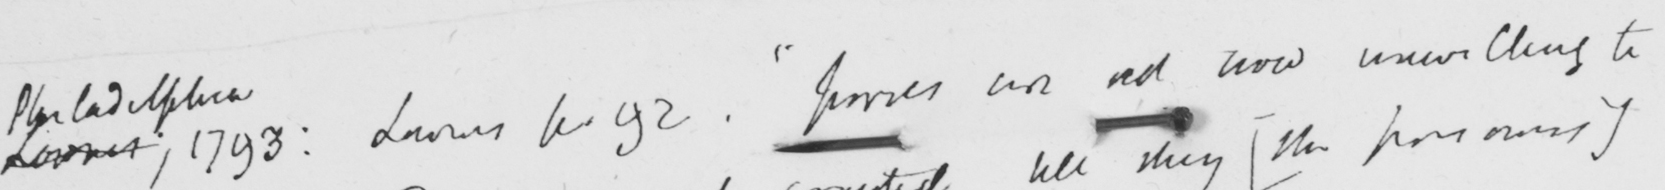What is written in this line of handwriting? <gap/>  ; 1793 :   <gap/>  p . 92 .  " Juries are not now unwilling to 